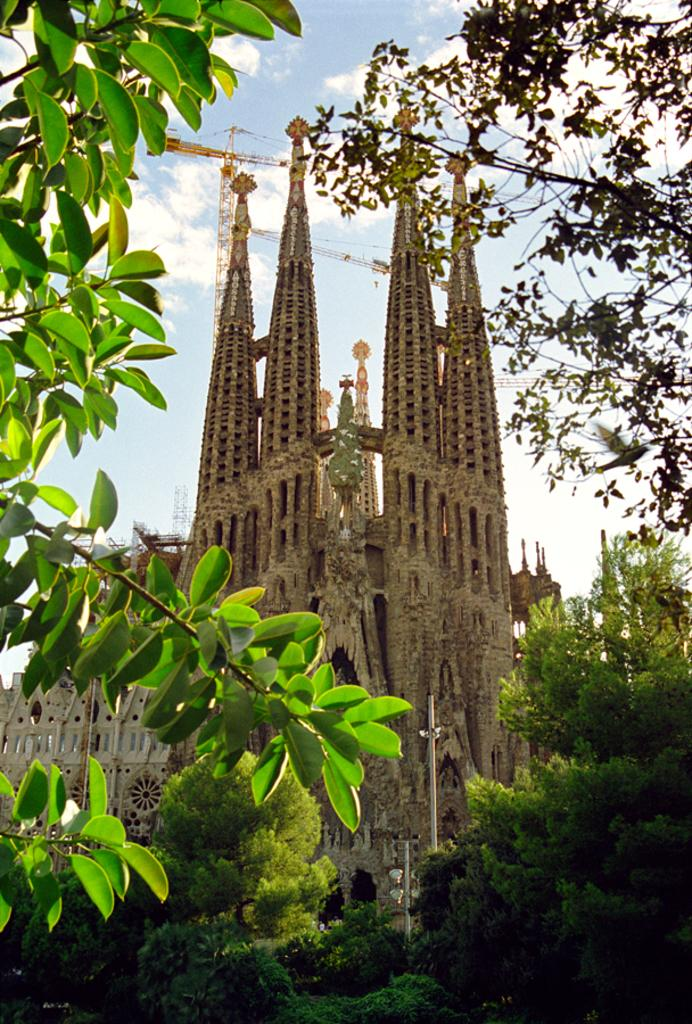What type of vegetation can be seen in the left corner of the image? There are leaves in the left corner of the image. Where else can vegetation be found in the image? There are trees on the right corner and in the foreground of the image. What architectural feature is present in the image? There is a spire in the image. What other objects can be seen in the image? There are poles in the image. What is visible at the top of the image? The sky is visible at the top of the image. What type of advertisement can be seen on the trees in the image? There are no advertisements present on the trees in the image; only leaves, trees, and a spire are visible. How many houses are depicted in the image? There are no houses depicted in the image; it features trees, a spire, and poles. 